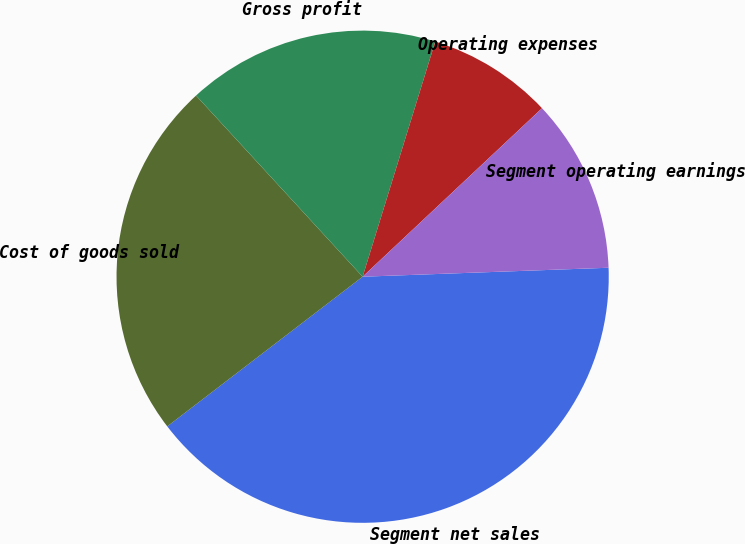Convert chart. <chart><loc_0><loc_0><loc_500><loc_500><pie_chart><fcel>Segment net sales<fcel>Cost of goods sold<fcel>Gross profit<fcel>Operating expenses<fcel>Segment operating earnings<nl><fcel>40.17%<fcel>23.57%<fcel>16.6%<fcel>8.23%<fcel>11.42%<nl></chart> 